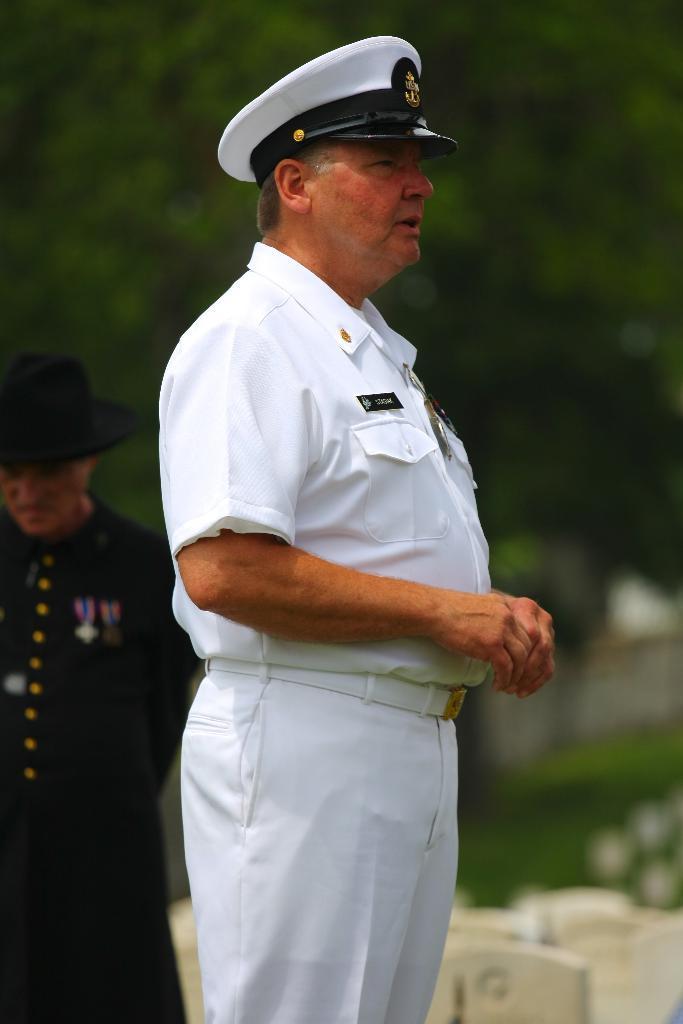Describe this image in one or two sentences. In the foreground of the image there is a person wearing white color uniform and a cap. Behind him there is a person wearing a black dress with a hat. In the background of the image there are trees. 